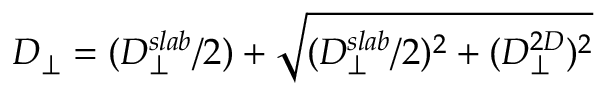<formula> <loc_0><loc_0><loc_500><loc_500>D _ { \perp } = ( D _ { \perp } ^ { s l a b } / 2 ) + \sqrt { ( D _ { \perp } ^ { s l a b } / 2 ) ^ { 2 } + ( D _ { \perp } ^ { 2 D } ) ^ { 2 } }</formula> 